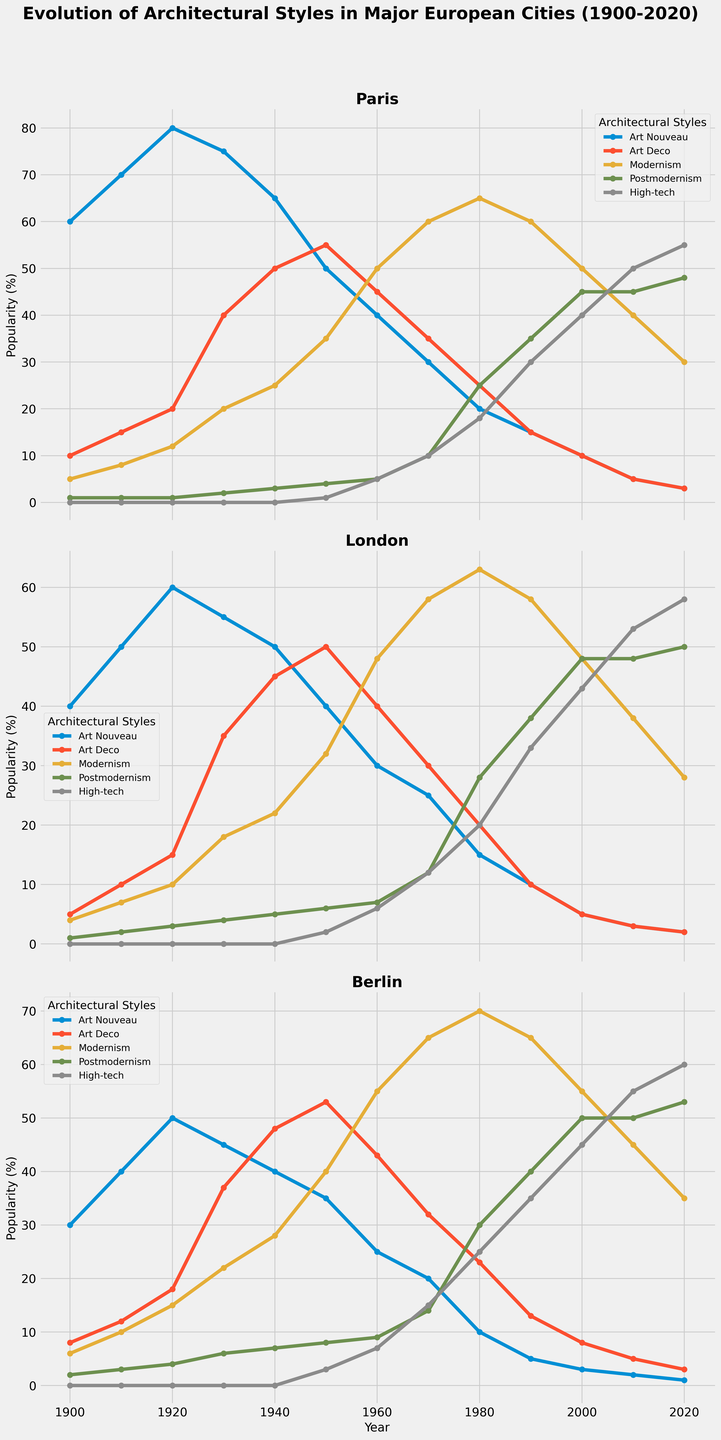Which architectural style was the most popular in Paris in the 1950s? Look at the line chart for Paris in the 1950s. The style with the highest value on the y-axis will be the most popular. For Paris, Modernism dominates with a value of 35%.
Answer: Modernism Which city saw the highest popularity of Art Nouveau in 1900? Compare the line charts for Paris, London, and Berlin in 1900. We see Paris has the highest popularity for Art Nouveau at 60%.
Answer: Paris How did the popularity of Postmodernism change in London from 2000 to 2020? Look at the Postmodernism line for London from 2000 to 2020. In 2000, it starts at 48% and rises slightly to 50% by 2020.
Answer: Increased What's the sum of the popularity values for High-tech in Berlin in the decades of the 2000s and 2010s? Check the popularity values for High-tech in Berlin in 2000 (45) and 2010 (55). Sum them up: 45 + 55 = 100.
Answer: 100 Which city had the highest popularity of High-tech architecture in 2020? Compare the High-tech values for Paris, London, and Berlin in 2020. Berlin has the highest with 60%.
Answer: Berlin Was Art Deco more popular than Art Nouveau in Berlin during the 1940s? Look at the Art Deco and Art Nouveau lines for Berlin in the 1940s. Art Deco stands at 48%, whereas Art Nouveau is at 40%.
Answer: Yes Compare the trends of Modernism and High-tech in Paris from 1980 to 2020. Which one had a growing trend? Observe the line charts in Paris from 1980 to 2020. The Modernism line consistently declines while the High-tech line steadily rises.
Answer: High-tech What is the average popularity of Postmodernism in London from 1980 to 2020? Check the Postmodernism values for London in 1980 (28), 1990 (38), 2000 (48), 2010 (48), and 2020 (50). Calculate the average: (28 + 38 + 48 + 48 + 50) / 5 = 42.4.
Answer: 42.4 Which style saw the sharpest decline in popularity in Paris from 1930 to 2020? Examine the line charts for all styles in Paris between 1930 and 2020. Art Nouveau drops from 75% in 1930 to 3% in 2020, the sharpest decline.
Answer: Art Nouveau 